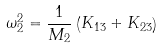<formula> <loc_0><loc_0><loc_500><loc_500>\omega _ { 2 } ^ { 2 } = \frac { 1 } { M _ { 2 } } \left ( K _ { 1 3 } + K _ { 2 3 } \right )</formula> 